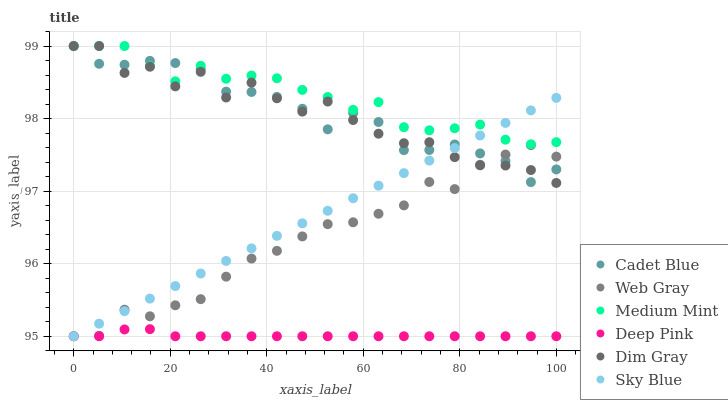Does Deep Pink have the minimum area under the curve?
Answer yes or no. Yes. Does Medium Mint have the maximum area under the curve?
Answer yes or no. Yes. Does Dim Gray have the minimum area under the curve?
Answer yes or no. No. Does Dim Gray have the maximum area under the curve?
Answer yes or no. No. Is Sky Blue the smoothest?
Answer yes or no. Yes. Is Dim Gray the roughest?
Answer yes or no. Yes. Is Deep Pink the smoothest?
Answer yes or no. No. Is Deep Pink the roughest?
Answer yes or no. No. Does Deep Pink have the lowest value?
Answer yes or no. Yes. Does Dim Gray have the lowest value?
Answer yes or no. No. Does Cadet Blue have the highest value?
Answer yes or no. Yes. Does Deep Pink have the highest value?
Answer yes or no. No. Is Deep Pink less than Cadet Blue?
Answer yes or no. Yes. Is Medium Mint greater than Web Gray?
Answer yes or no. Yes. Does Deep Pink intersect Sky Blue?
Answer yes or no. Yes. Is Deep Pink less than Sky Blue?
Answer yes or no. No. Is Deep Pink greater than Sky Blue?
Answer yes or no. No. Does Deep Pink intersect Cadet Blue?
Answer yes or no. No. 